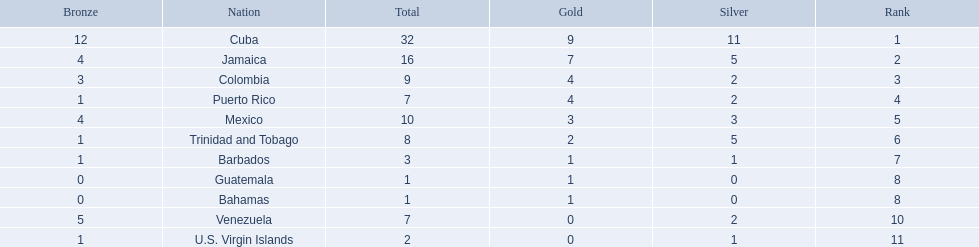Which 3 countries were awarded the most medals? Cuba, Jamaica, Colombia. Of these 3 countries which ones are islands? Cuba, Jamaica. Which one won the most silver medals? Cuba. 